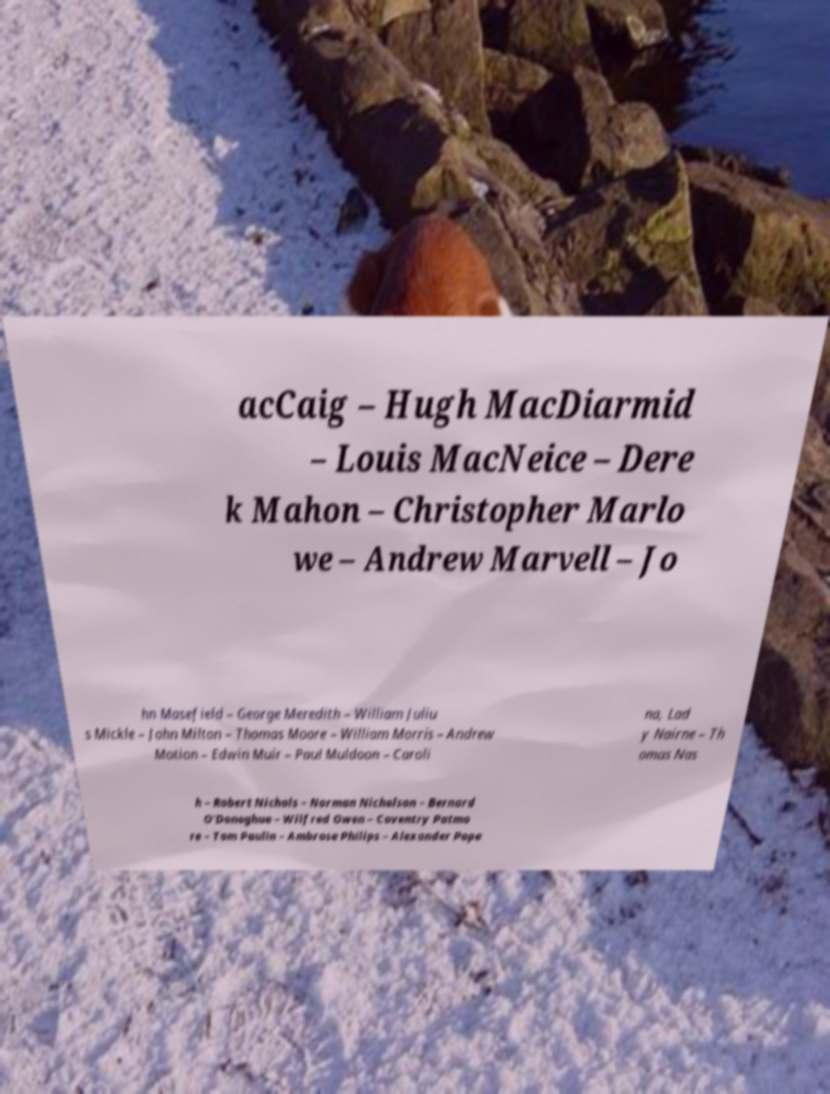For documentation purposes, I need the text within this image transcribed. Could you provide that? acCaig – Hugh MacDiarmid – Louis MacNeice – Dere k Mahon – Christopher Marlo we – Andrew Marvell – Jo hn Masefield – George Meredith – William Juliu s Mickle – John Milton – Thomas Moore – William Morris – Andrew Motion – Edwin Muir – Paul Muldoon – Caroli na, Lad y Nairne – Th omas Nas h – Robert Nichols – Norman Nicholson – Bernard O'Donoghue – Wilfred Owen – Coventry Patmo re – Tom Paulin – Ambrose Philips – Alexander Pope 